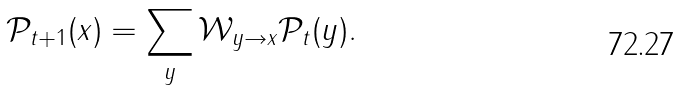Convert formula to latex. <formula><loc_0><loc_0><loc_500><loc_500>\mathcal { P } _ { t + 1 } ( { x } ) = \sum _ { y } \mathcal { W } _ { { y } \rightarrow { x } } \mathcal { P } _ { t } ( { y } ) .</formula> 